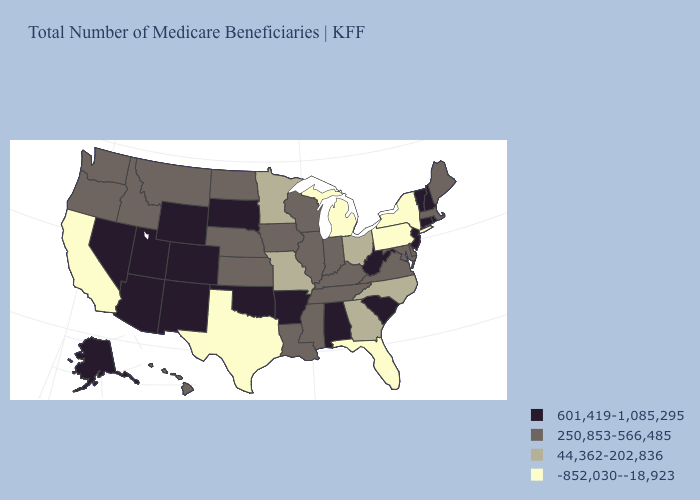Among the states that border New Mexico , does Arizona have the highest value?
Quick response, please. Yes. Among the states that border Washington , which have the highest value?
Concise answer only. Idaho, Oregon. What is the value of Michigan?
Answer briefly. -852,030--18,923. What is the lowest value in the South?
Give a very brief answer. -852,030--18,923. Is the legend a continuous bar?
Concise answer only. No. What is the value of Nevada?
Keep it brief. 601,419-1,085,295. What is the value of Georgia?
Short answer required. 44,362-202,836. Among the states that border Minnesota , does Iowa have the lowest value?
Short answer required. Yes. Does North Carolina have a lower value than Utah?
Give a very brief answer. Yes. Name the states that have a value in the range -852,030--18,923?
Give a very brief answer. California, Florida, Michigan, New York, Pennsylvania, Texas. What is the lowest value in the USA?
Write a very short answer. -852,030--18,923. What is the value of North Carolina?
Keep it brief. 44,362-202,836. Among the states that border New Jersey , which have the highest value?
Write a very short answer. Delaware. Does the map have missing data?
Answer briefly. No. Does South Dakota have the highest value in the USA?
Keep it brief. Yes. 